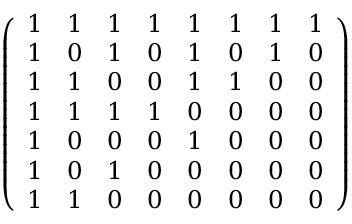Convert formula to latex. <formula><loc_0><loc_0><loc_500><loc_500>{ \left ( \begin{array} { l l l l l l l l } { 1 } & { 1 } & { 1 } & { 1 } & { 1 } & { 1 } & { 1 } & { 1 } \\ { 1 } & { 0 } & { 1 } & { 0 } & { 1 } & { 0 } & { 1 } & { 0 } \\ { 1 } & { 1 } & { 0 } & { 0 } & { 1 } & { 1 } & { 0 } & { 0 } \\ { 1 } & { 1 } & { 1 } & { 1 } & { 0 } & { 0 } & { 0 } & { 0 } \\ { 1 } & { 0 } & { 0 } & { 0 } & { 1 } & { 0 } & { 0 } & { 0 } \\ { 1 } & { 0 } & { 1 } & { 0 } & { 0 } & { 0 } & { 0 } & { 0 } \\ { 1 } & { 1 } & { 0 } & { 0 } & { 0 } & { 0 } & { 0 } & { 0 } \end{array} \right ) }</formula> 